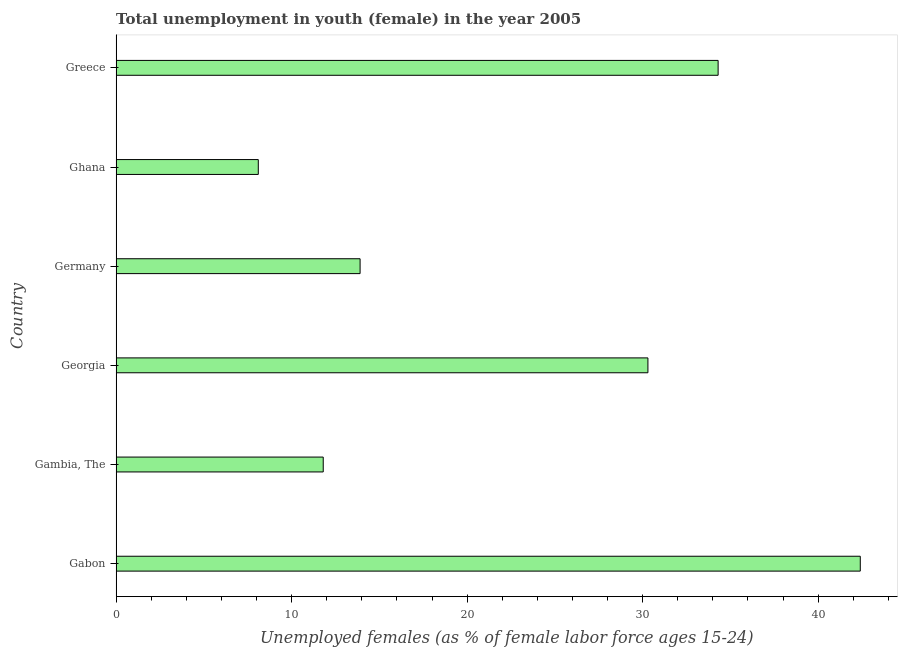Does the graph contain grids?
Your response must be concise. No. What is the title of the graph?
Offer a very short reply. Total unemployment in youth (female) in the year 2005. What is the label or title of the X-axis?
Make the answer very short. Unemployed females (as % of female labor force ages 15-24). What is the label or title of the Y-axis?
Keep it short and to the point. Country. What is the unemployed female youth population in Germany?
Offer a very short reply. 13.9. Across all countries, what is the maximum unemployed female youth population?
Provide a succinct answer. 42.4. Across all countries, what is the minimum unemployed female youth population?
Your answer should be compact. 8.1. In which country was the unemployed female youth population maximum?
Offer a very short reply. Gabon. What is the sum of the unemployed female youth population?
Your answer should be very brief. 140.8. What is the difference between the unemployed female youth population in Gambia, The and Greece?
Keep it short and to the point. -22.5. What is the average unemployed female youth population per country?
Ensure brevity in your answer.  23.47. What is the median unemployed female youth population?
Offer a terse response. 22.1. In how many countries, is the unemployed female youth population greater than 18 %?
Offer a very short reply. 3. What is the ratio of the unemployed female youth population in Gabon to that in Greece?
Provide a short and direct response. 1.24. Is the unemployed female youth population in Gabon less than that in Ghana?
Provide a short and direct response. No. Is the difference between the unemployed female youth population in Gabon and Greece greater than the difference between any two countries?
Your answer should be compact. No. What is the difference between the highest and the second highest unemployed female youth population?
Make the answer very short. 8.1. What is the difference between the highest and the lowest unemployed female youth population?
Offer a very short reply. 34.3. In how many countries, is the unemployed female youth population greater than the average unemployed female youth population taken over all countries?
Provide a succinct answer. 3. How many countries are there in the graph?
Your answer should be compact. 6. What is the Unemployed females (as % of female labor force ages 15-24) in Gabon?
Your response must be concise. 42.4. What is the Unemployed females (as % of female labor force ages 15-24) of Gambia, The?
Keep it short and to the point. 11.8. What is the Unemployed females (as % of female labor force ages 15-24) of Georgia?
Make the answer very short. 30.3. What is the Unemployed females (as % of female labor force ages 15-24) in Germany?
Offer a very short reply. 13.9. What is the Unemployed females (as % of female labor force ages 15-24) in Ghana?
Give a very brief answer. 8.1. What is the Unemployed females (as % of female labor force ages 15-24) in Greece?
Offer a terse response. 34.3. What is the difference between the Unemployed females (as % of female labor force ages 15-24) in Gabon and Gambia, The?
Ensure brevity in your answer.  30.6. What is the difference between the Unemployed females (as % of female labor force ages 15-24) in Gabon and Germany?
Provide a short and direct response. 28.5. What is the difference between the Unemployed females (as % of female labor force ages 15-24) in Gabon and Ghana?
Ensure brevity in your answer.  34.3. What is the difference between the Unemployed females (as % of female labor force ages 15-24) in Gambia, The and Georgia?
Your answer should be very brief. -18.5. What is the difference between the Unemployed females (as % of female labor force ages 15-24) in Gambia, The and Germany?
Your answer should be compact. -2.1. What is the difference between the Unemployed females (as % of female labor force ages 15-24) in Gambia, The and Greece?
Your response must be concise. -22.5. What is the difference between the Unemployed females (as % of female labor force ages 15-24) in Georgia and Greece?
Your answer should be compact. -4. What is the difference between the Unemployed females (as % of female labor force ages 15-24) in Germany and Ghana?
Ensure brevity in your answer.  5.8. What is the difference between the Unemployed females (as % of female labor force ages 15-24) in Germany and Greece?
Give a very brief answer. -20.4. What is the difference between the Unemployed females (as % of female labor force ages 15-24) in Ghana and Greece?
Keep it short and to the point. -26.2. What is the ratio of the Unemployed females (as % of female labor force ages 15-24) in Gabon to that in Gambia, The?
Your response must be concise. 3.59. What is the ratio of the Unemployed females (as % of female labor force ages 15-24) in Gabon to that in Georgia?
Make the answer very short. 1.4. What is the ratio of the Unemployed females (as % of female labor force ages 15-24) in Gabon to that in Germany?
Ensure brevity in your answer.  3.05. What is the ratio of the Unemployed females (as % of female labor force ages 15-24) in Gabon to that in Ghana?
Provide a short and direct response. 5.24. What is the ratio of the Unemployed females (as % of female labor force ages 15-24) in Gabon to that in Greece?
Keep it short and to the point. 1.24. What is the ratio of the Unemployed females (as % of female labor force ages 15-24) in Gambia, The to that in Georgia?
Your answer should be very brief. 0.39. What is the ratio of the Unemployed females (as % of female labor force ages 15-24) in Gambia, The to that in Germany?
Provide a succinct answer. 0.85. What is the ratio of the Unemployed females (as % of female labor force ages 15-24) in Gambia, The to that in Ghana?
Make the answer very short. 1.46. What is the ratio of the Unemployed females (as % of female labor force ages 15-24) in Gambia, The to that in Greece?
Give a very brief answer. 0.34. What is the ratio of the Unemployed females (as % of female labor force ages 15-24) in Georgia to that in Germany?
Your response must be concise. 2.18. What is the ratio of the Unemployed females (as % of female labor force ages 15-24) in Georgia to that in Ghana?
Your answer should be very brief. 3.74. What is the ratio of the Unemployed females (as % of female labor force ages 15-24) in Georgia to that in Greece?
Your answer should be very brief. 0.88. What is the ratio of the Unemployed females (as % of female labor force ages 15-24) in Germany to that in Ghana?
Your answer should be very brief. 1.72. What is the ratio of the Unemployed females (as % of female labor force ages 15-24) in Germany to that in Greece?
Keep it short and to the point. 0.41. What is the ratio of the Unemployed females (as % of female labor force ages 15-24) in Ghana to that in Greece?
Provide a short and direct response. 0.24. 